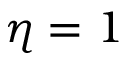<formula> <loc_0><loc_0><loc_500><loc_500>\eta = 1</formula> 